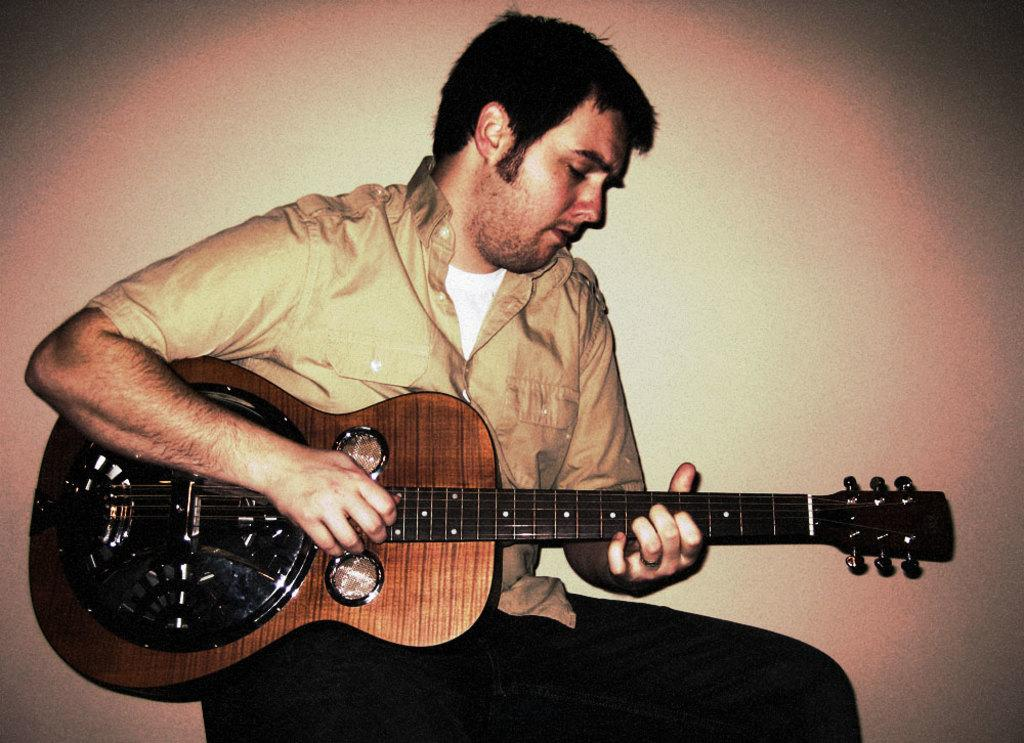Who is the main subject in the image? There is a man in the image. What is the man doing in the image? The man is sitting and playing a musical instrument. What type of leather is the man using to play the musical instrument in the image? There is no leather mentioned or visible in the image; the man is playing a musical instrument, but the material it is made of is not specified. 